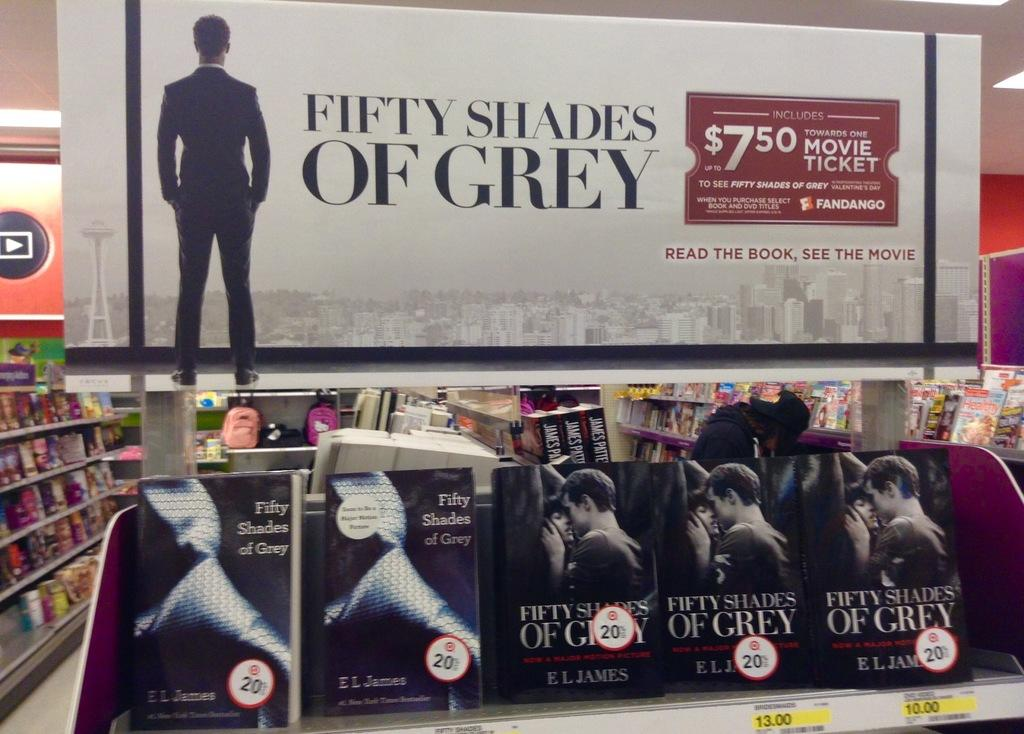<image>
Give a short and clear explanation of the subsequent image. a book display for a book that is called Fifty Shades of Grey 